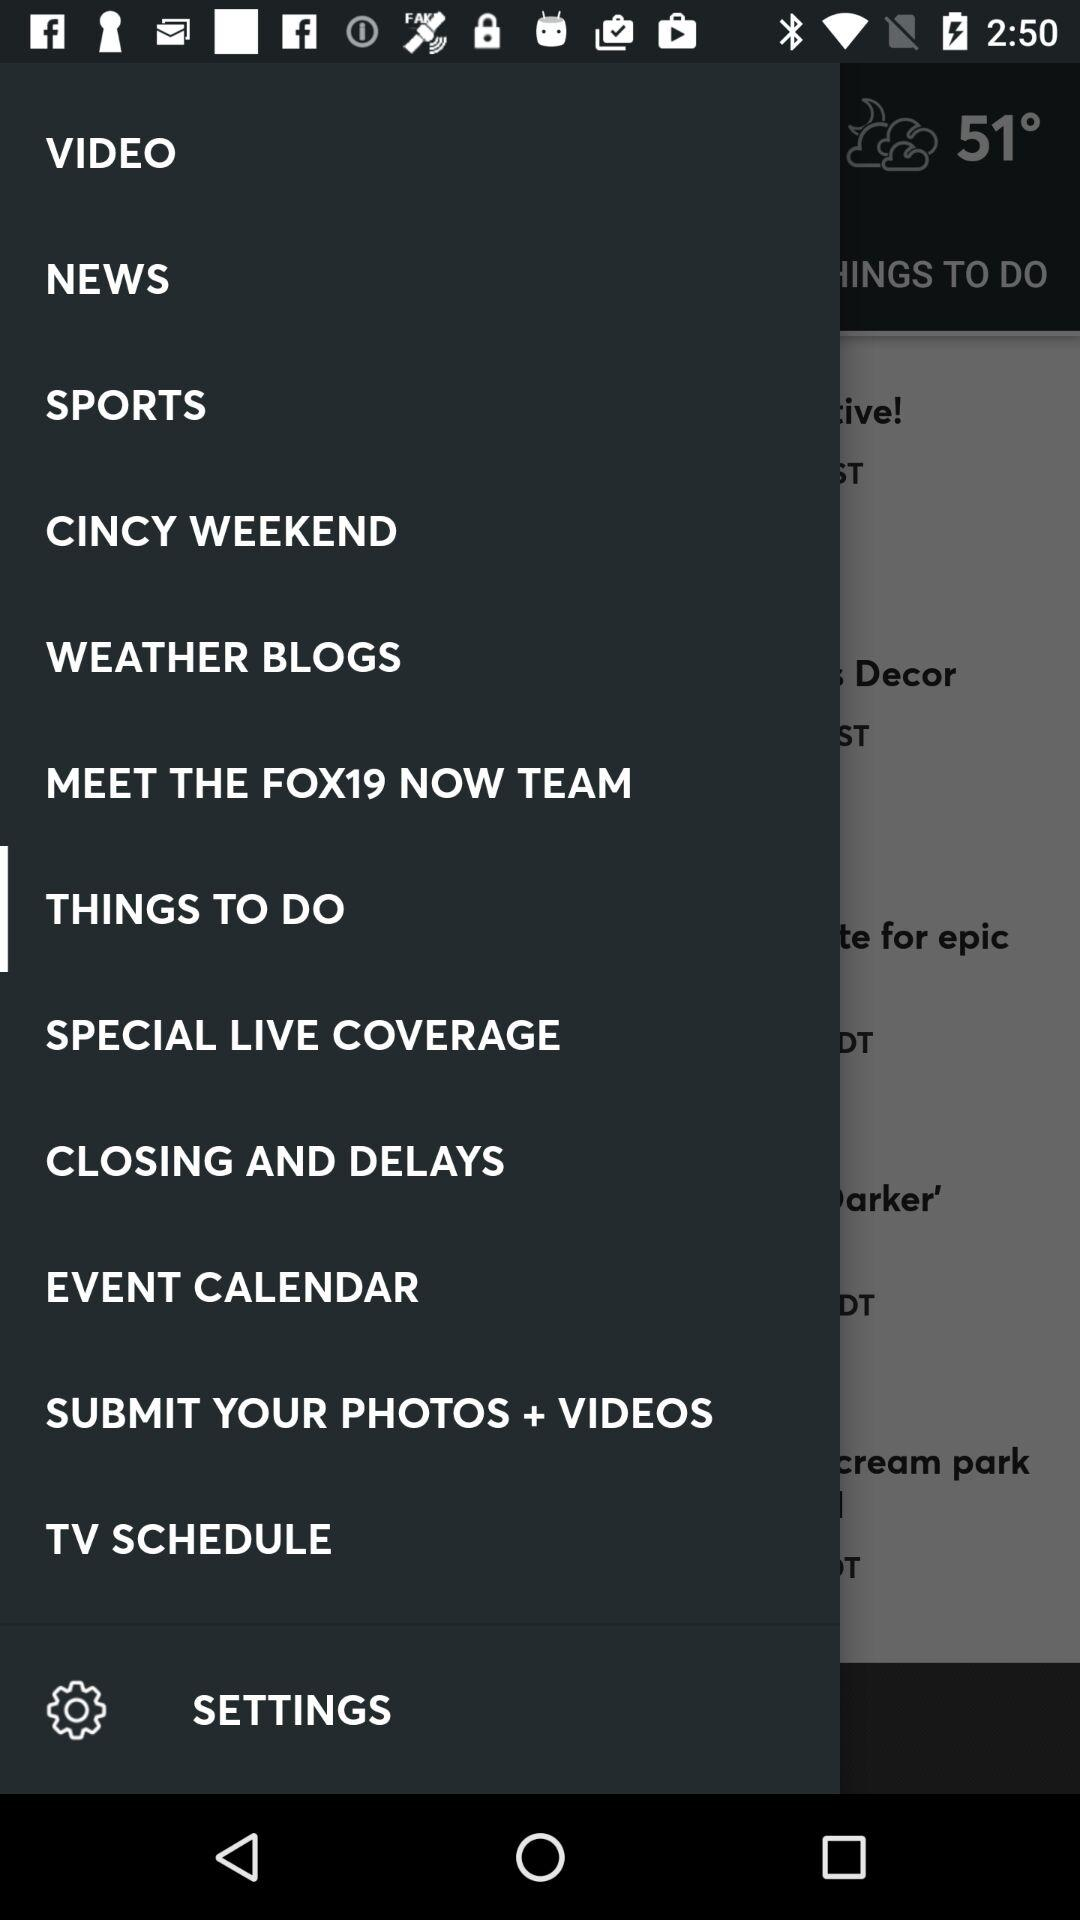What is the temperature? The temperature is 51°. 